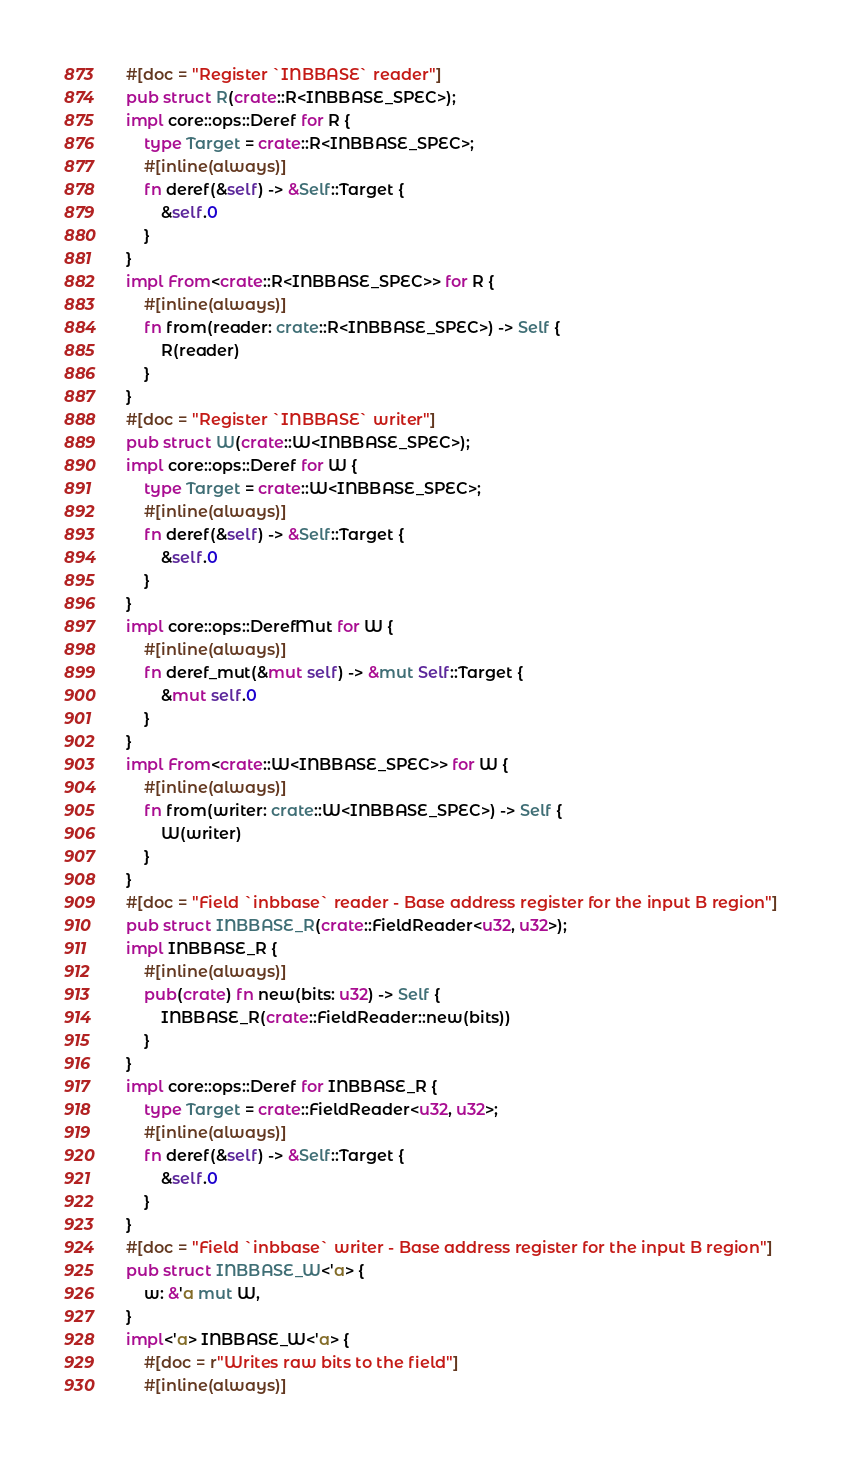<code> <loc_0><loc_0><loc_500><loc_500><_Rust_>#[doc = "Register `INBBASE` reader"]
pub struct R(crate::R<INBBASE_SPEC>);
impl core::ops::Deref for R {
    type Target = crate::R<INBBASE_SPEC>;
    #[inline(always)]
    fn deref(&self) -> &Self::Target {
        &self.0
    }
}
impl From<crate::R<INBBASE_SPEC>> for R {
    #[inline(always)]
    fn from(reader: crate::R<INBBASE_SPEC>) -> Self {
        R(reader)
    }
}
#[doc = "Register `INBBASE` writer"]
pub struct W(crate::W<INBBASE_SPEC>);
impl core::ops::Deref for W {
    type Target = crate::W<INBBASE_SPEC>;
    #[inline(always)]
    fn deref(&self) -> &Self::Target {
        &self.0
    }
}
impl core::ops::DerefMut for W {
    #[inline(always)]
    fn deref_mut(&mut self) -> &mut Self::Target {
        &mut self.0
    }
}
impl From<crate::W<INBBASE_SPEC>> for W {
    #[inline(always)]
    fn from(writer: crate::W<INBBASE_SPEC>) -> Self {
        W(writer)
    }
}
#[doc = "Field `inbbase` reader - Base address register for the input B region"]
pub struct INBBASE_R(crate::FieldReader<u32, u32>);
impl INBBASE_R {
    #[inline(always)]
    pub(crate) fn new(bits: u32) -> Self {
        INBBASE_R(crate::FieldReader::new(bits))
    }
}
impl core::ops::Deref for INBBASE_R {
    type Target = crate::FieldReader<u32, u32>;
    #[inline(always)]
    fn deref(&self) -> &Self::Target {
        &self.0
    }
}
#[doc = "Field `inbbase` writer - Base address register for the input B region"]
pub struct INBBASE_W<'a> {
    w: &'a mut W,
}
impl<'a> INBBASE_W<'a> {
    #[doc = r"Writes raw bits to the field"]
    #[inline(always)]</code> 